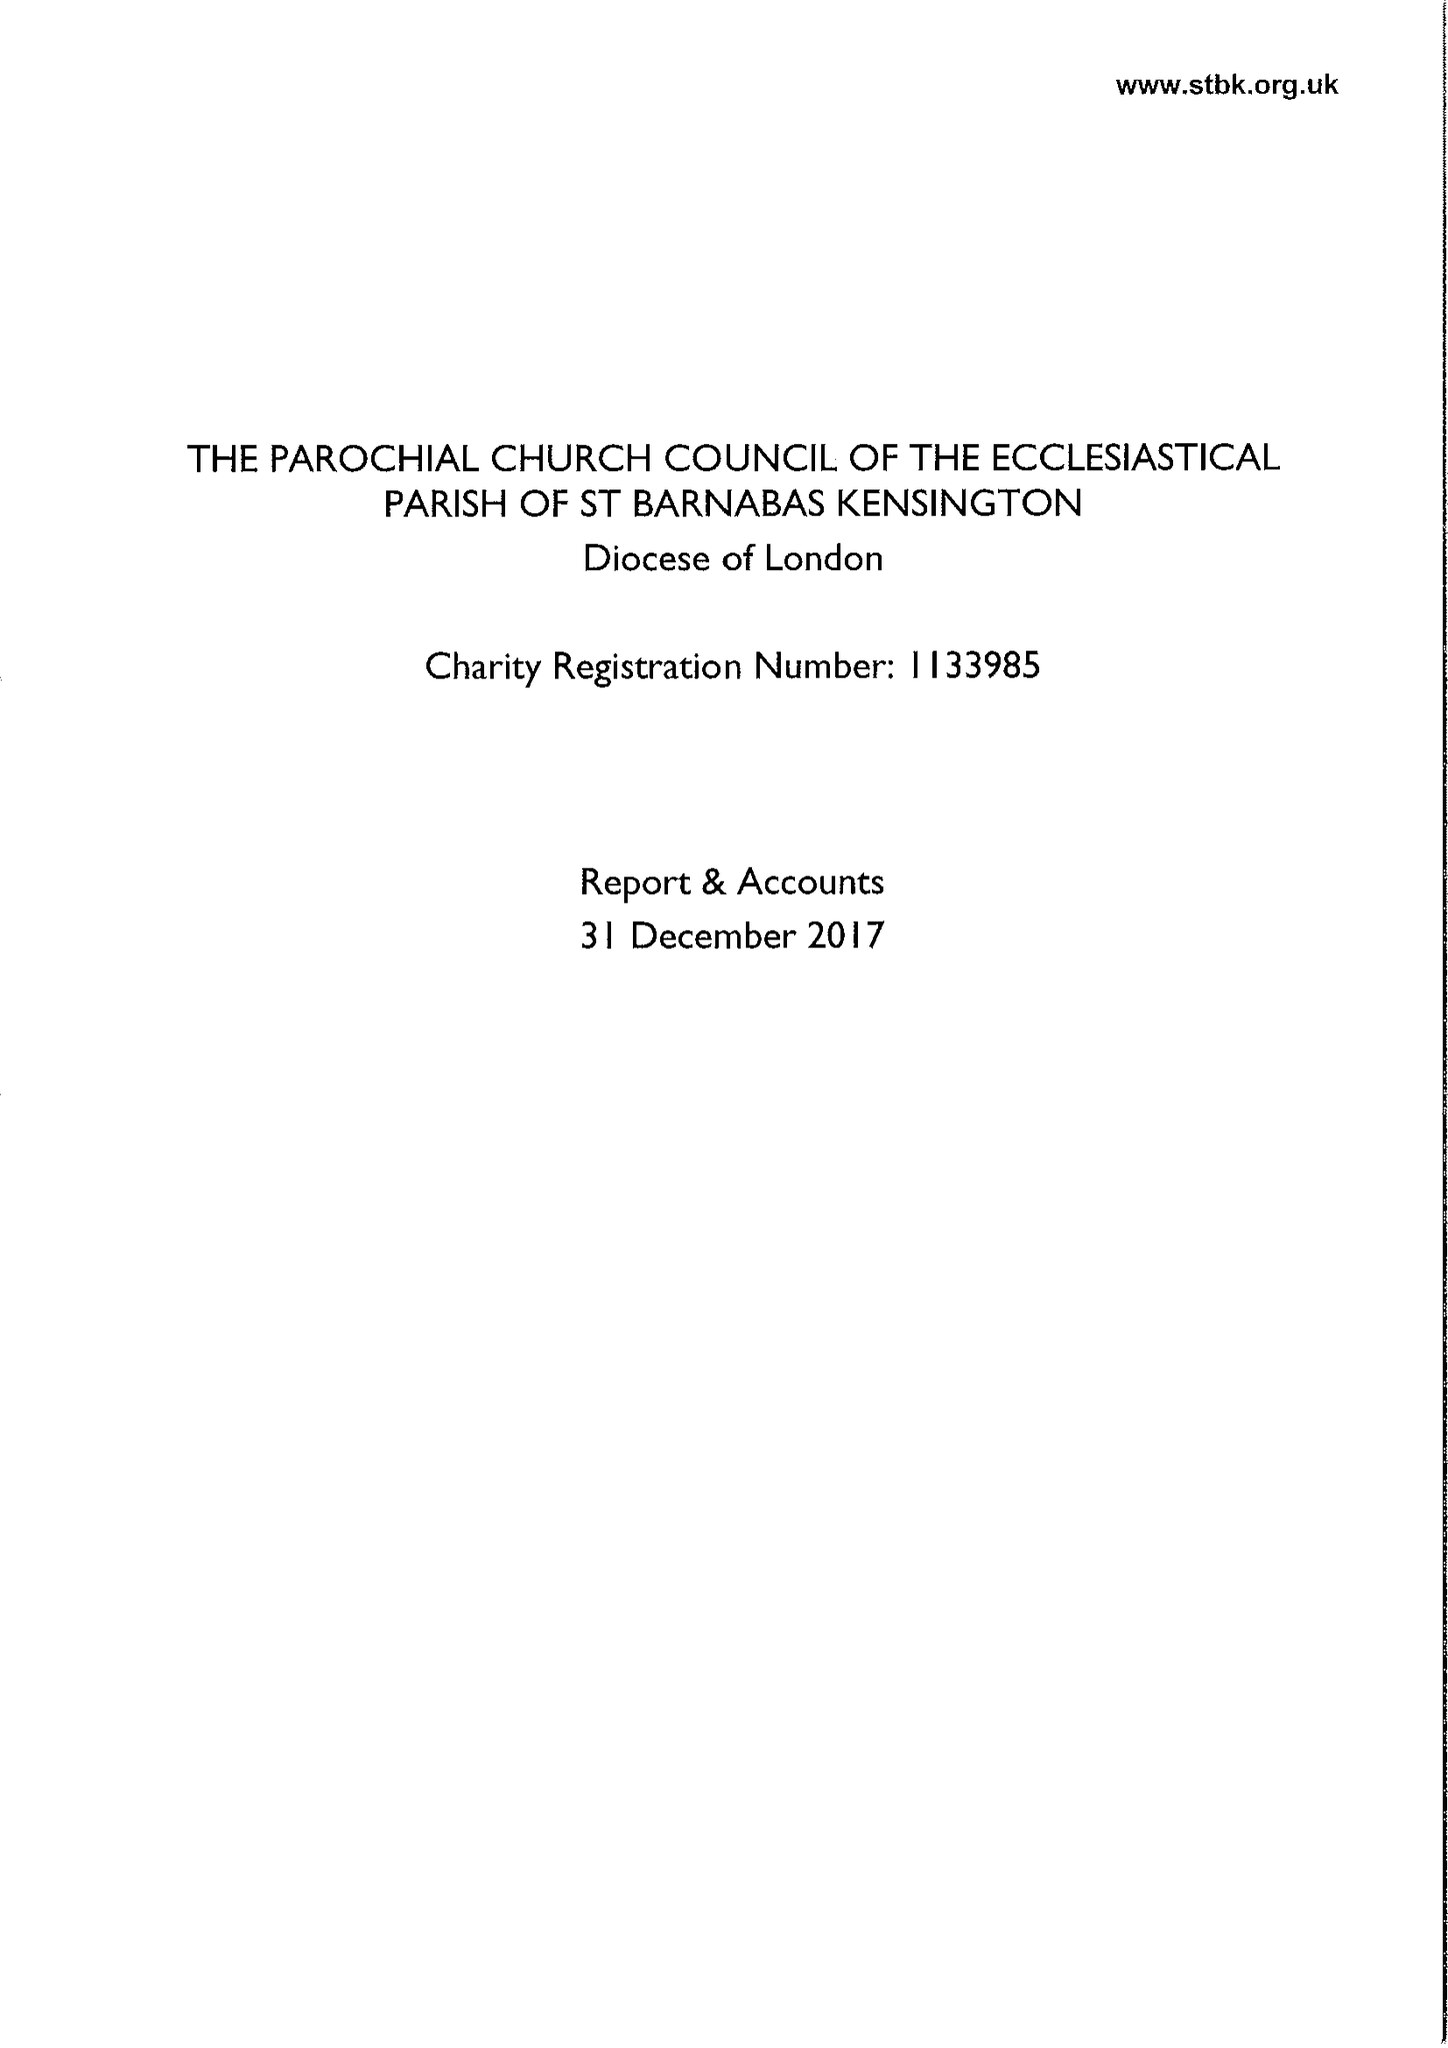What is the value for the charity_number?
Answer the question using a single word or phrase. 1133985 